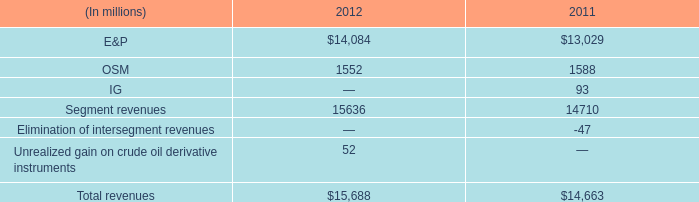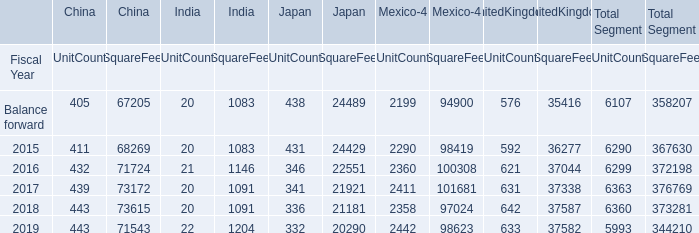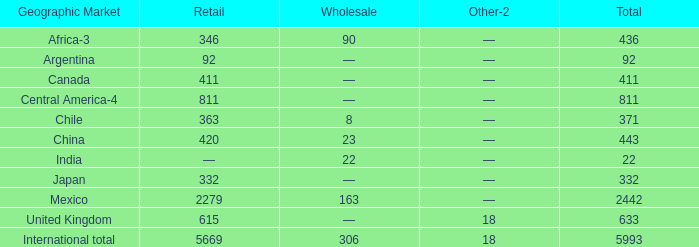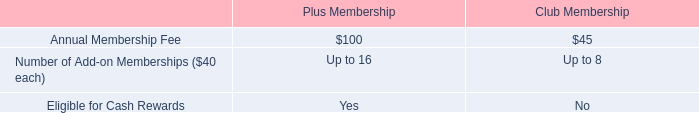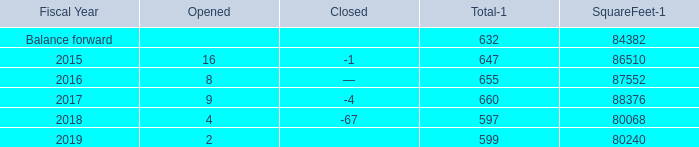What is the average amount of Balance forward of SquareFeet, and 2015 of Mexico UnitCount ? 
Computations: ((84382.0 + 2290.0) / 2)
Answer: 43336.0. 